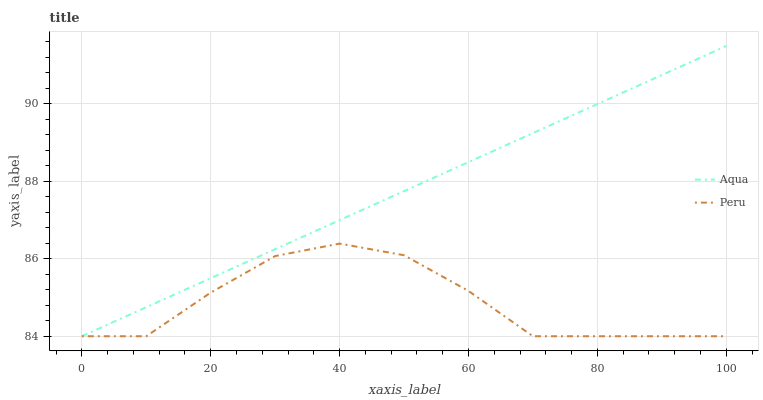Does Peru have the minimum area under the curve?
Answer yes or no. Yes. Does Aqua have the maximum area under the curve?
Answer yes or no. Yes. Does Peru have the maximum area under the curve?
Answer yes or no. No. Is Aqua the smoothest?
Answer yes or no. Yes. Is Peru the roughest?
Answer yes or no. Yes. Is Peru the smoothest?
Answer yes or no. No. Does Aqua have the highest value?
Answer yes or no. Yes. Does Peru have the highest value?
Answer yes or no. No. 